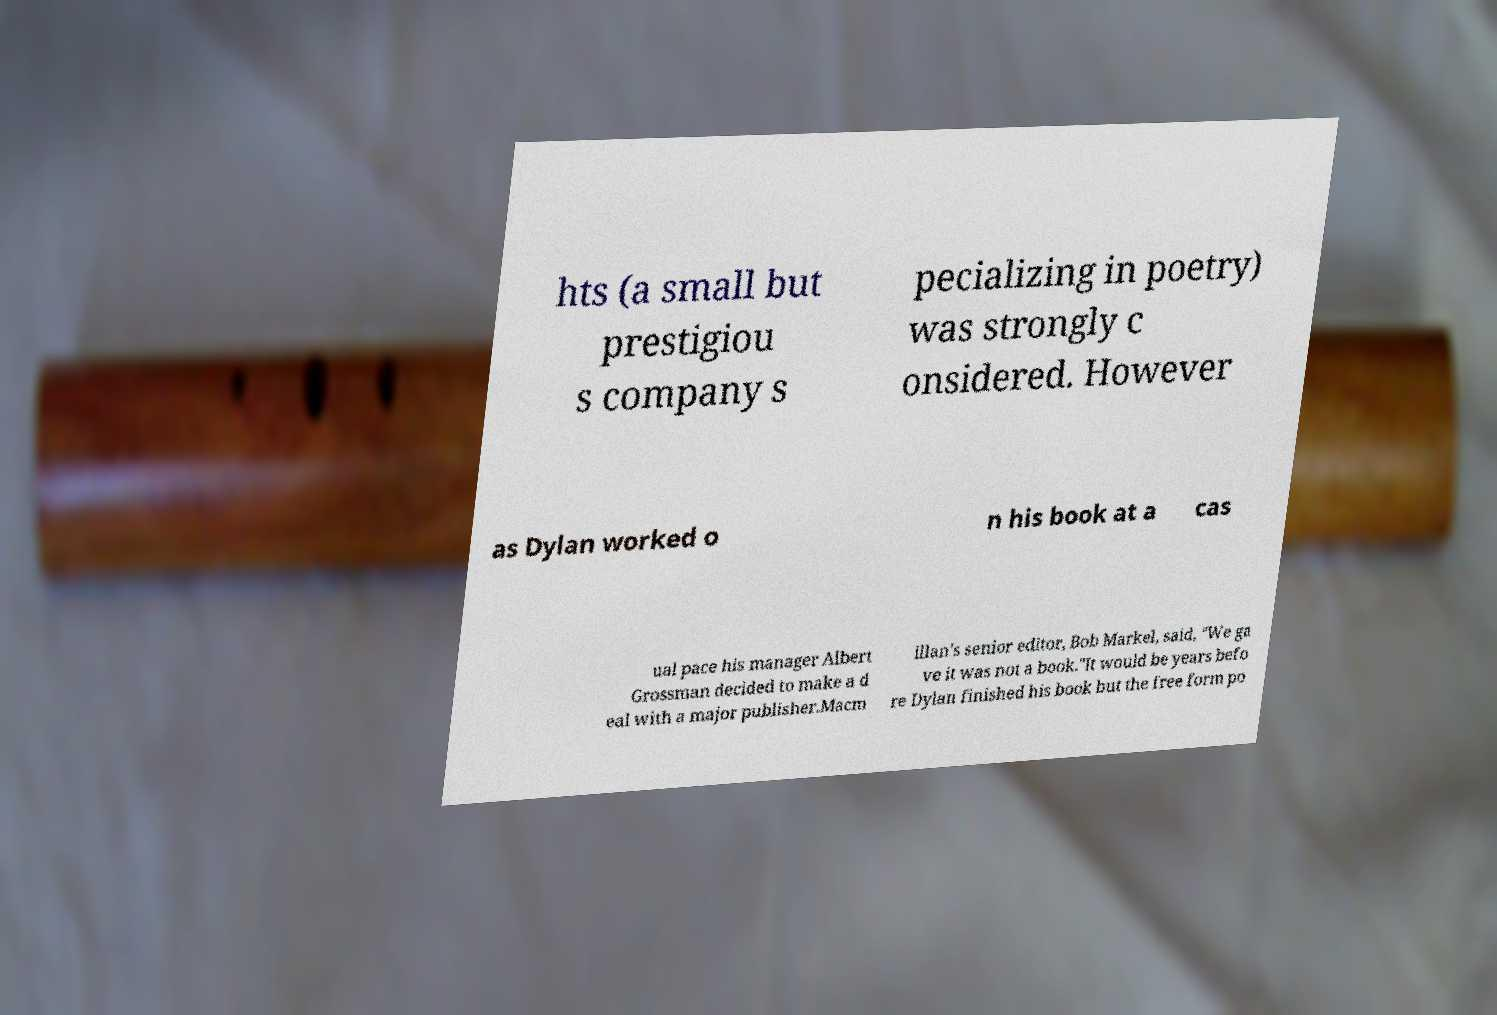Please identify and transcribe the text found in this image. hts (a small but prestigiou s company s pecializing in poetry) was strongly c onsidered. However as Dylan worked o n his book at a cas ual pace his manager Albert Grossman decided to make a d eal with a major publisher.Macm illan's senior editor, Bob Markel, said, "We ga ve it was not a book."It would be years befo re Dylan finished his book but the free form po 